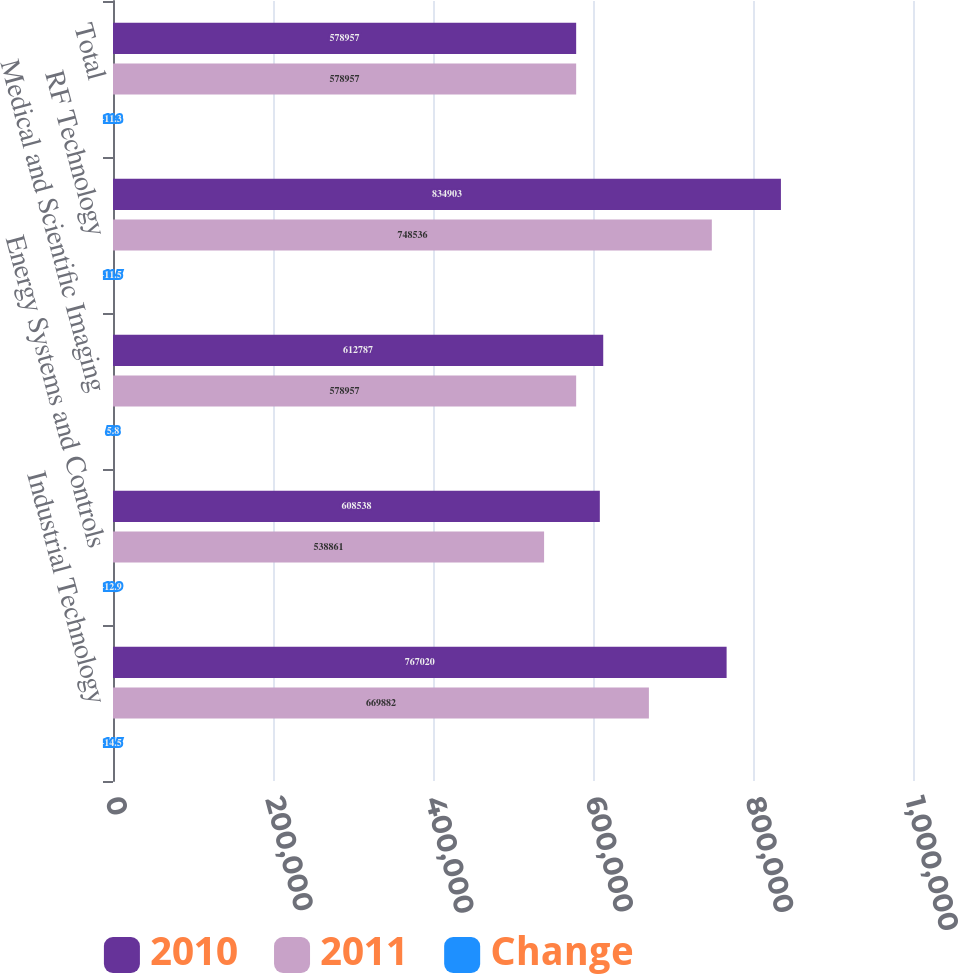<chart> <loc_0><loc_0><loc_500><loc_500><stacked_bar_chart><ecel><fcel>Industrial Technology<fcel>Energy Systems and Controls<fcel>Medical and Scientific Imaging<fcel>RF Technology<fcel>Total<nl><fcel>2010<fcel>767020<fcel>608538<fcel>612787<fcel>834903<fcel>578957<nl><fcel>2011<fcel>669882<fcel>538861<fcel>578957<fcel>748536<fcel>578957<nl><fcel>Change<fcel>14.5<fcel>12.9<fcel>5.8<fcel>11.5<fcel>11.3<nl></chart> 